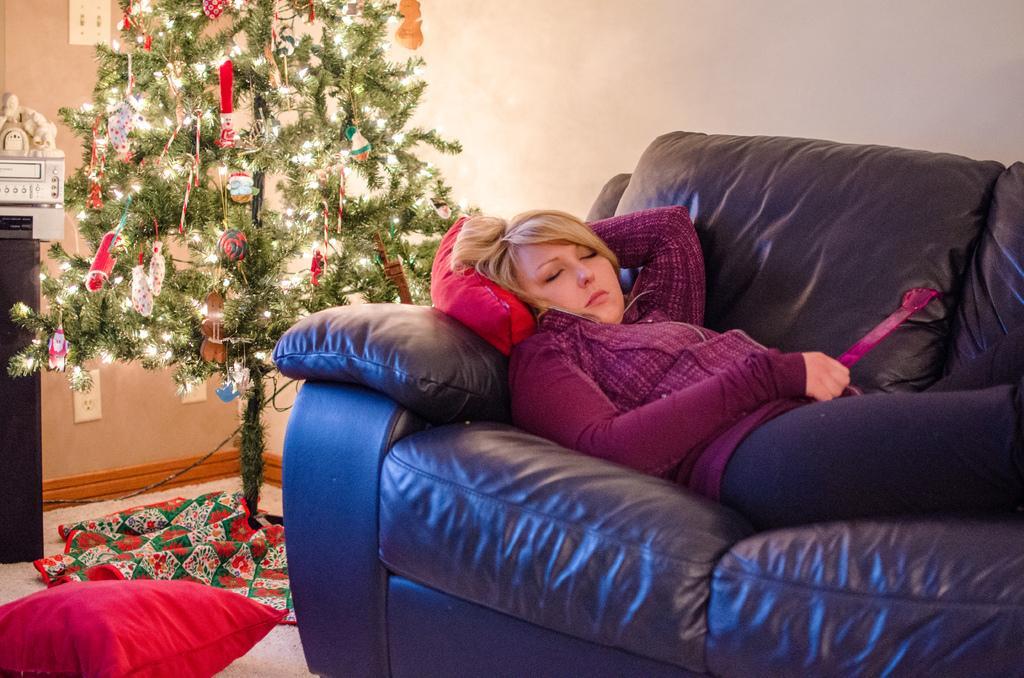In one or two sentences, can you explain what this image depicts? The image is taken in the room. On the right side of the image there is lady sleeping on the sofa. There is a cushion placed on the floor. In the background there is a xmas tree and wall. 